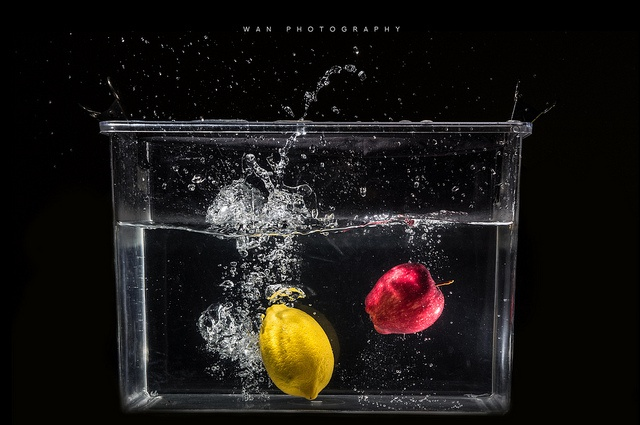Describe the objects in this image and their specific colors. I can see a apple in black, brown, maroon, and salmon tones in this image. 